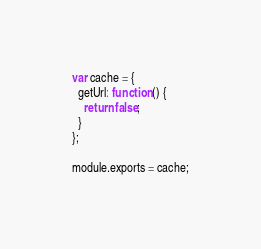Convert code to text. <code><loc_0><loc_0><loc_500><loc_500><_JavaScript_>var cache = {
  getUrl: function () {
    return false;
  }
};

module.exports = cache;
</code> 